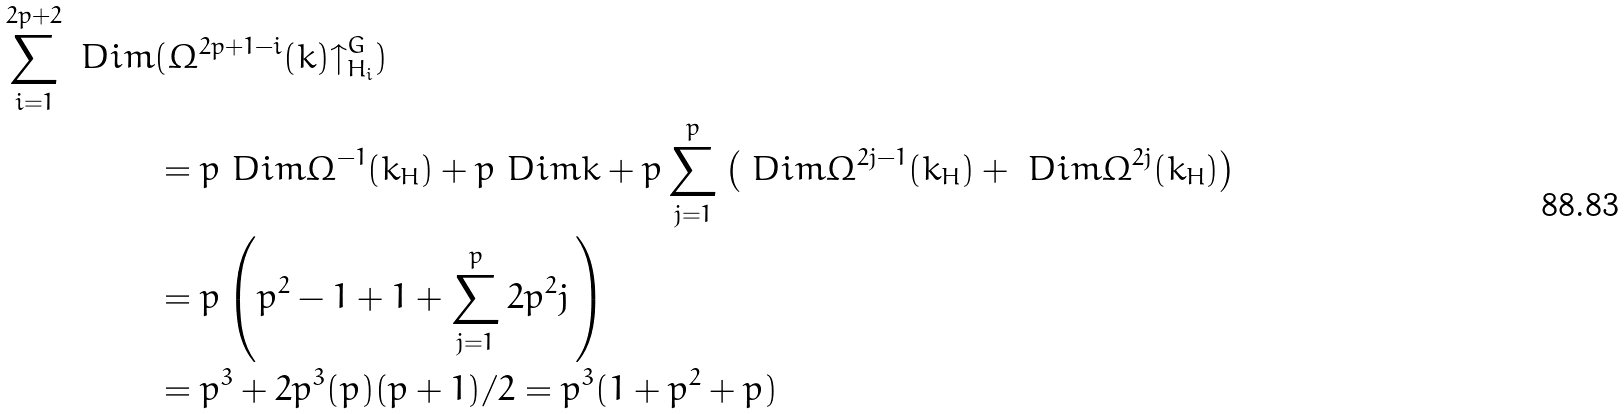Convert formula to latex. <formula><loc_0><loc_0><loc_500><loc_500>\sum _ { i = 1 } ^ { 2 p + 2 } \ D i m & ( \Omega ^ { 2 p + 1 - i } ( k ) { \uparrow } _ { H _ { i } } ^ { G } ) \\ & = p \ D i m \Omega ^ { - 1 } ( k _ { H } ) + p \ D i m k + p \sum _ { j = 1 } ^ { p } \left ( \ D i m \Omega ^ { 2 j - 1 } ( k _ { H } ) + \ D i m \Omega ^ { 2 j } ( k _ { H } ) \right ) \\ & = p \left ( p ^ { 2 } - 1 + 1 + \sum _ { j = 1 } ^ { p } 2 p ^ { 2 } j \, \right ) \\ & = p ^ { 3 } + 2 p ^ { 3 } ( p ) ( p + 1 ) / 2 = p ^ { 3 } ( 1 + p ^ { 2 } + p )</formula> 